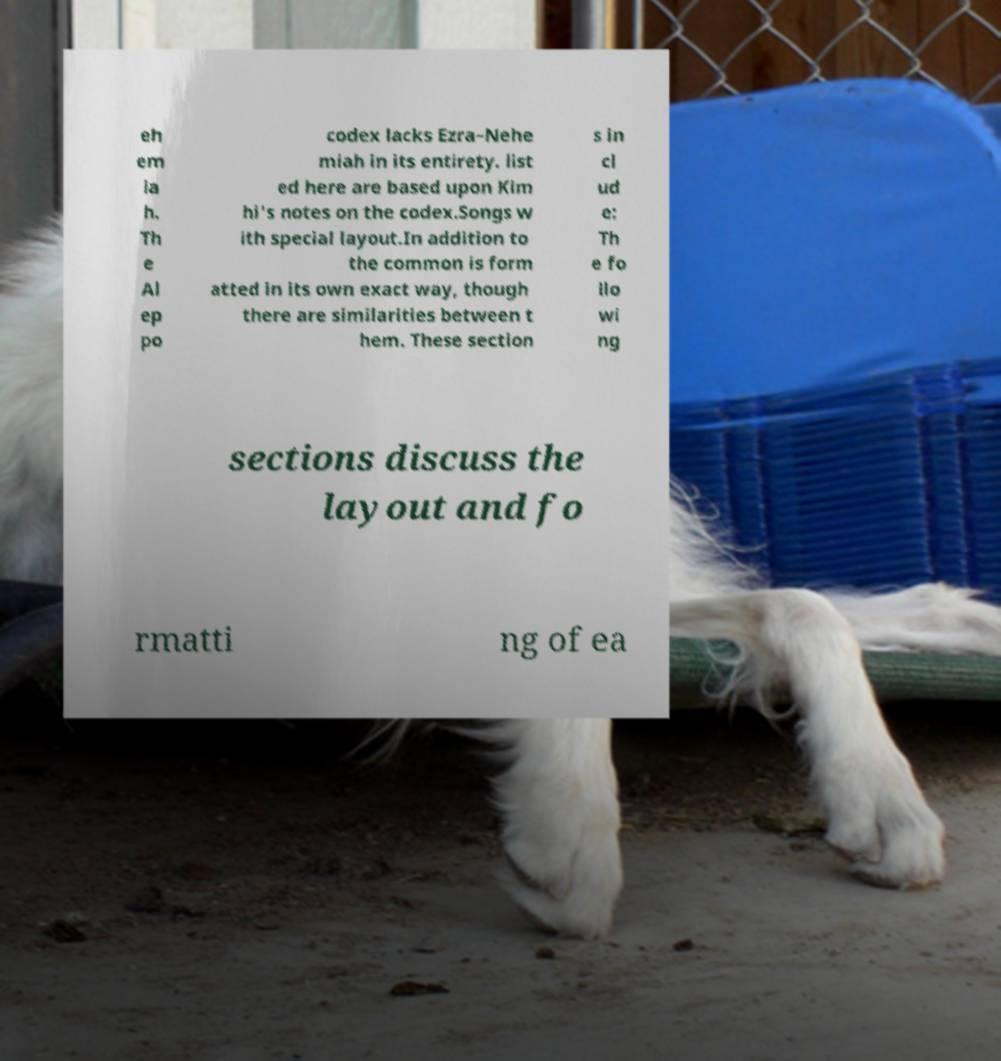Please identify and transcribe the text found in this image. eh em ia h. Th e Al ep po codex lacks Ezra–Nehe miah in its entirety. list ed here are based upon Kim hi's notes on the codex.Songs w ith special layout.In addition to the common is form atted in its own exact way, though there are similarities between t hem. These section s in cl ud e: Th e fo llo wi ng sections discuss the layout and fo rmatti ng of ea 